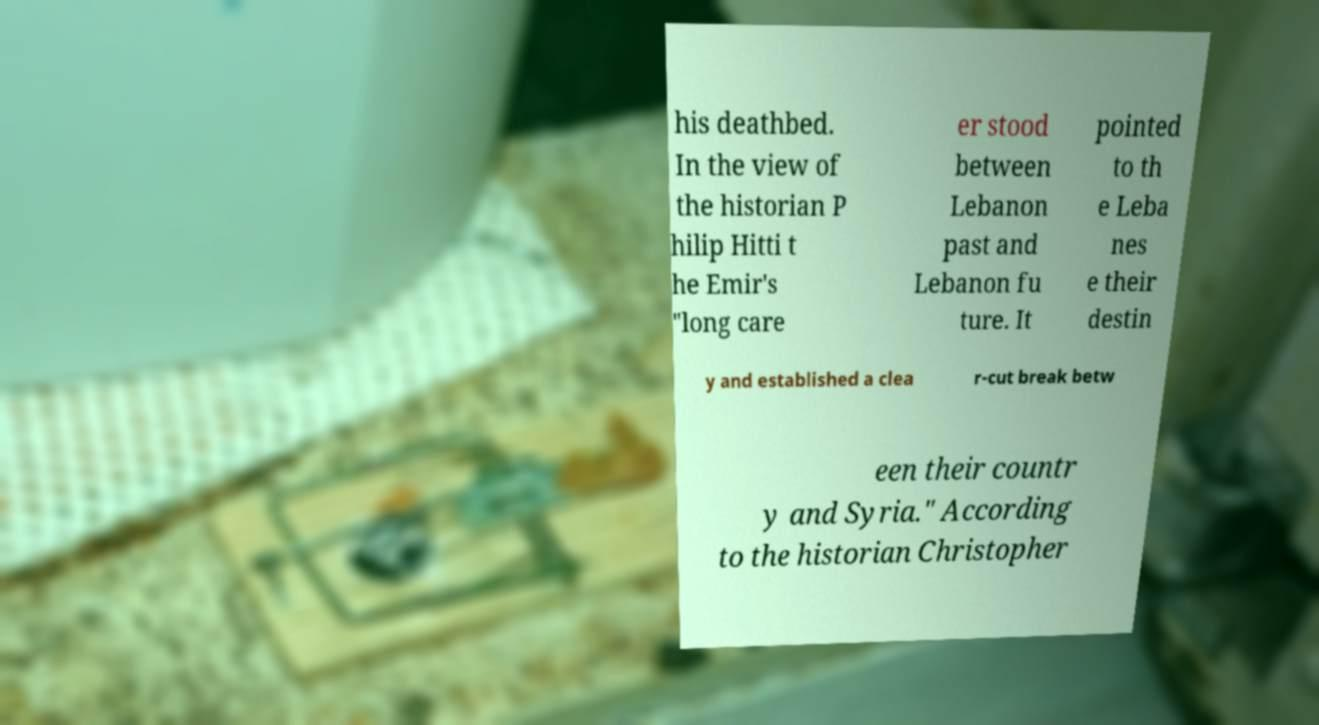Please read and relay the text visible in this image. What does it say? his deathbed. In the view of the historian P hilip Hitti t he Emir's "long care er stood between Lebanon past and Lebanon fu ture. It pointed to th e Leba nes e their destin y and established a clea r-cut break betw een their countr y and Syria." According to the historian Christopher 